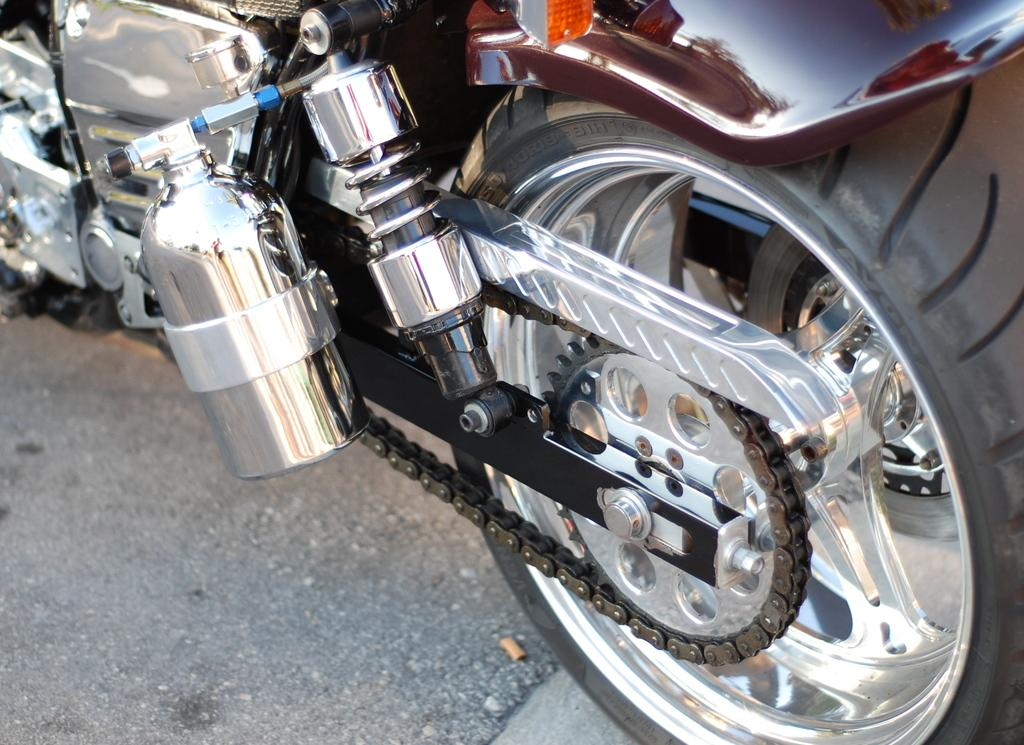What is the main object visible in the image? There is a wheel in the image. What other component can be seen in the image? There is a chain socket in the image. What can be inferred about the image based on the presence of these objects? The image appears to be a partial or truncated view of a vehicle. How many fingers can be seen in the image? There are no fingers visible in the image. What type of trousers is the person wearing in the image? There is no person present in the image, so it is not possible to determine what type of trousers they might be wearing. 